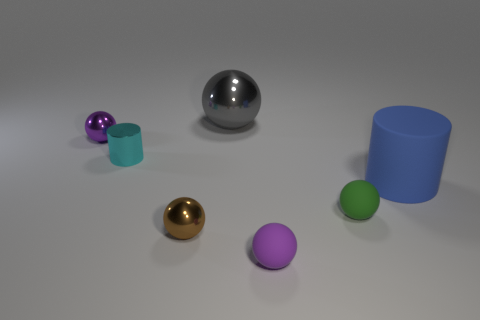Subtract all cyan cylinders. How many cylinders are left? 1 Subtract all brown balls. How many balls are left? 4 Subtract all spheres. How many objects are left? 2 Subtract 3 balls. How many balls are left? 2 Subtract all purple cylinders. Subtract all gray blocks. How many cylinders are left? 2 Subtract all blue cubes. How many yellow cylinders are left? 0 Subtract all gray balls. Subtract all blue cylinders. How many objects are left? 5 Add 2 cyan cylinders. How many cyan cylinders are left? 3 Add 4 small purple matte balls. How many small purple matte balls exist? 5 Add 2 cyan matte balls. How many objects exist? 9 